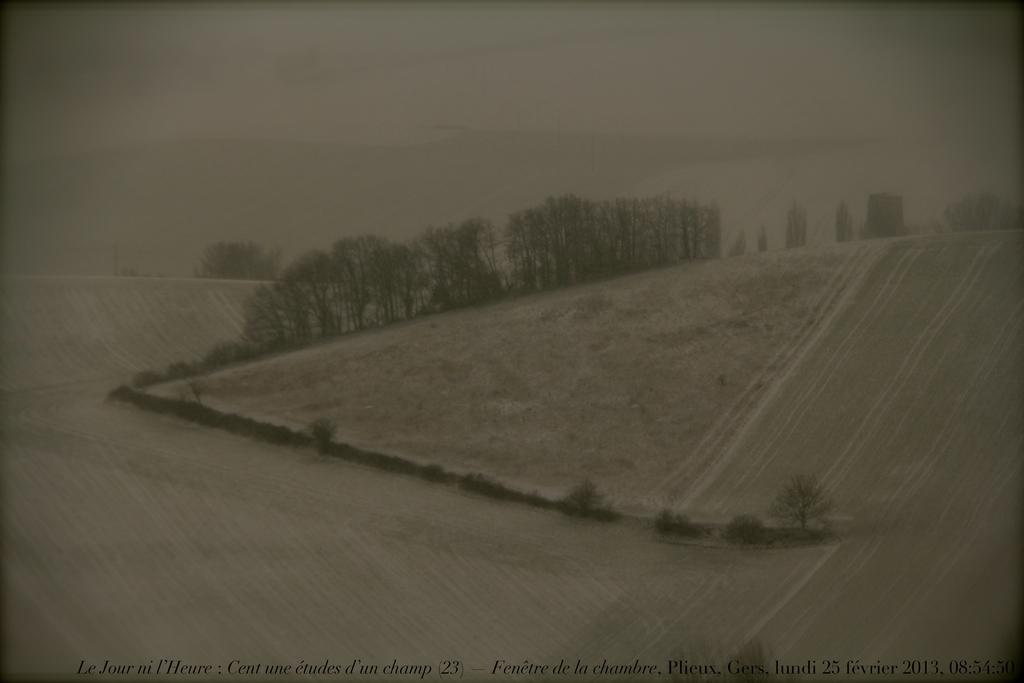What type of vegetation can be seen in the image? There are trees and plants in the image. What kind of landscape feature is present in the image? There are hills in the image. Is there any indication of the image's origin or ownership? Yes, there is a watermark on the image. What position does the root hold in the game being played in the image? There is no game being played in the image, and therefore no position for a root. 